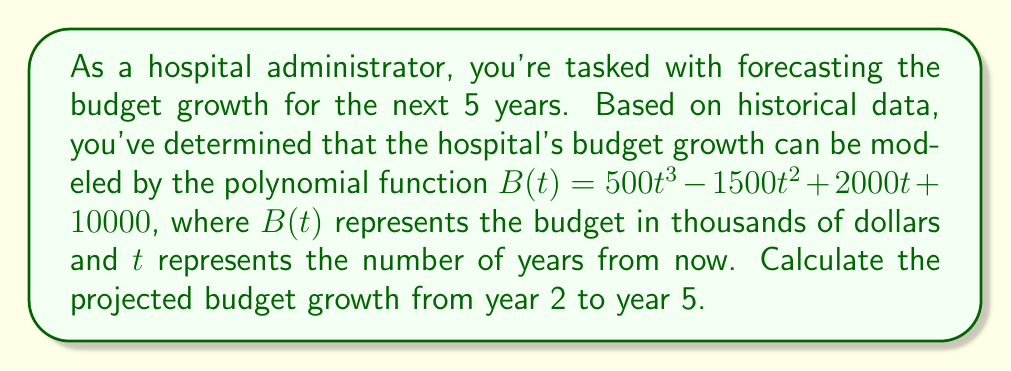Solve this math problem. To solve this problem, we need to follow these steps:

1) Calculate the budget for year 2: $B(2)$
2) Calculate the budget for year 5: $B(5)$
3) Subtract the year 2 budget from the year 5 budget to find the growth

Step 1: Calculate $B(2)$
$$\begin{align}
B(2) &= 500(2)^3 - 1500(2)^2 + 2000(2) + 10000 \\
&= 500(8) - 1500(4) + 2000(2) + 10000 \\
&= 4000 - 6000 + 4000 + 10000 \\
&= 12000
\end{align}$$

Step 2: Calculate $B(5)$
$$\begin{align}
B(5) &= 500(5)^3 - 1500(5)^2 + 2000(5) + 10000 \\
&= 500(125) - 1500(25) + 2000(5) + 10000 \\
&= 62500 - 37500 + 10000 + 10000 \\
&= 45000
\end{align}$$

Step 3: Calculate the growth
Budget growth = $B(5) - B(2)$
$$ 45000 - 12000 = 33000 $$

Therefore, the projected budget growth from year 2 to year 5 is 33,000 thousand dollars, or $33 million.
Answer: $33 million 